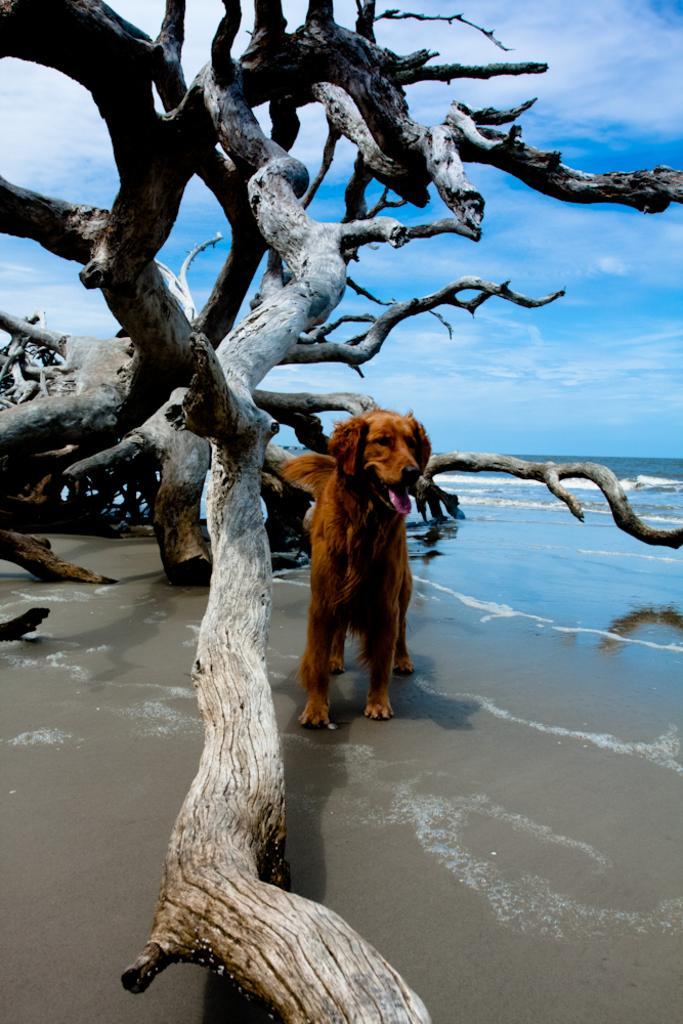Please provide a concise description of this image. In this image we can see a dog is standing on the sand at the water and the cut down bare trees. In the background we can see clouds in the sky. 